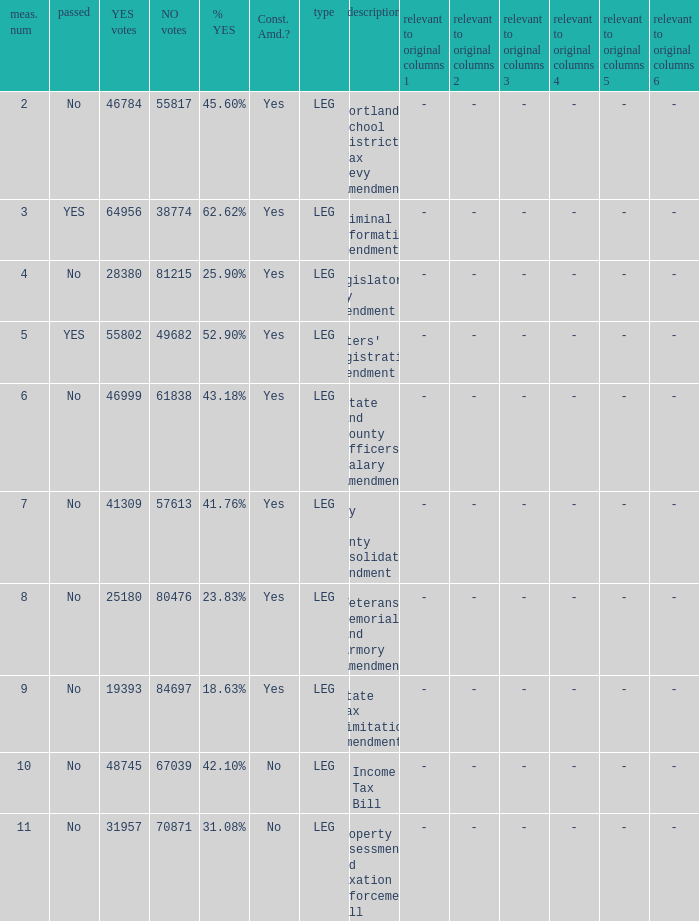How many yes votes made up 43.18% yes? 46999.0. 